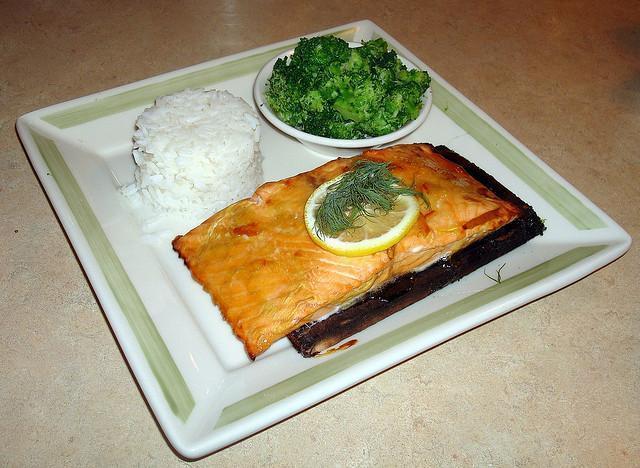How many different kinds of food are there?
Give a very brief answer. 3. How many bears are there?
Give a very brief answer. 0. 